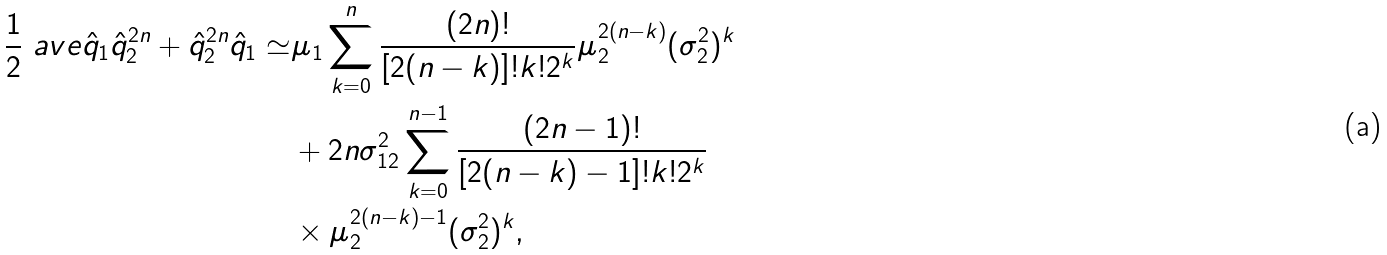<formula> <loc_0><loc_0><loc_500><loc_500>\frac { 1 } { 2 } \ a v e { \hat { q } _ { 1 } \hat { q } _ { 2 } ^ { 2 n } + \hat { q } _ { 2 } ^ { 2 n } \hat { q } _ { 1 } } \simeq & \mu _ { 1 } \sum _ { k = 0 } ^ { n } \frac { ( 2 n ) ! } { [ 2 ( n - k ) ] ! k ! 2 ^ { k } } \mu _ { 2 } ^ { 2 ( n - k ) } ( \sigma _ { 2 } ^ { 2 } ) ^ { k } \\ & + 2 n \sigma _ { 1 2 } ^ { 2 } \sum _ { k = 0 } ^ { n - 1 } \frac { ( 2 n - 1 ) ! } { [ 2 ( n - k ) - 1 ] ! k ! 2 ^ { k } } \\ & \times \mu _ { 2 } ^ { 2 ( n - k ) - 1 } ( \sigma _ { 2 } ^ { 2 } ) ^ { k } ,</formula> 